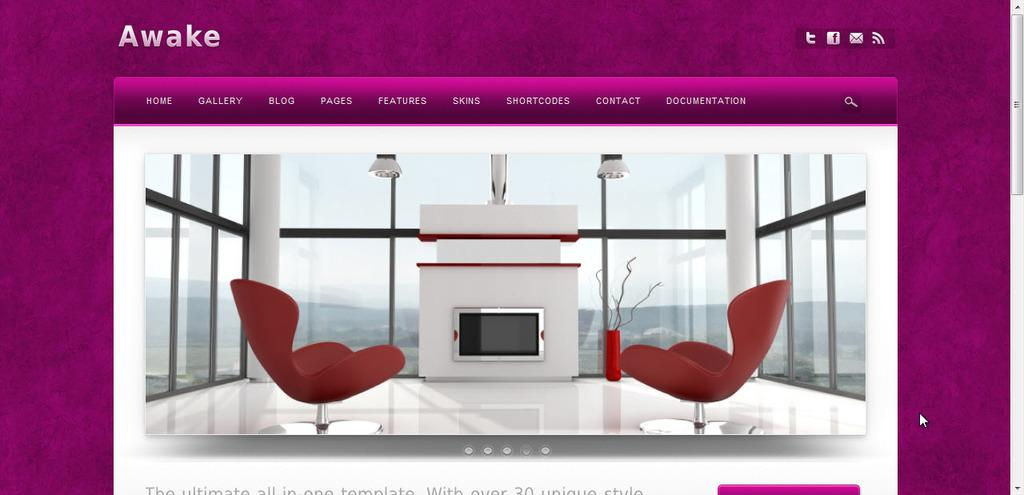<image>
Describe the image concisely. a screen shot reading AWAKE shows furniture in a modern white house 